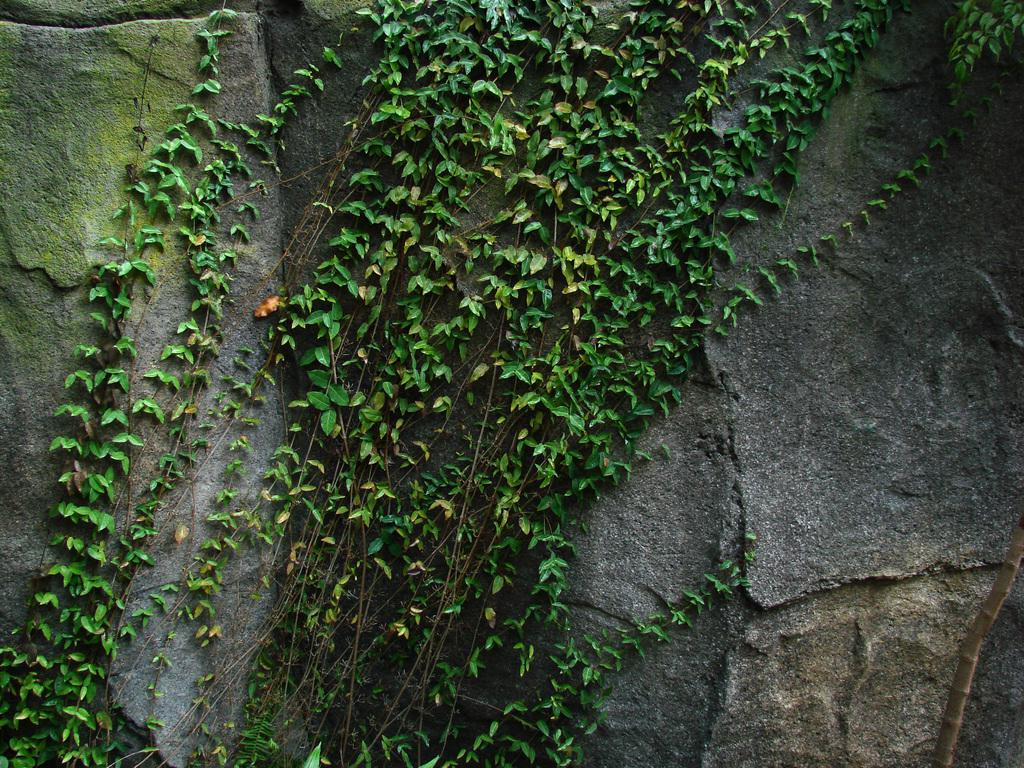What type of establishment is shown in the image? There is a store in the image. What can be seen on the store? Green leaf plants are present on the store. What object is located on the left side of the image? There is a stone on the left side of the image. What is growing on the stone? Algae is present on the stone. What letter is written on the store's sign in the image? There is no letter visible on the store's sign in the image. 